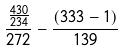Convert formula to latex. <formula><loc_0><loc_0><loc_500><loc_500>\frac { \frac { 4 3 0 } { 2 3 4 } } { 2 7 2 } - \frac { ( 3 3 3 - 1 ) } { 1 3 9 }</formula> 